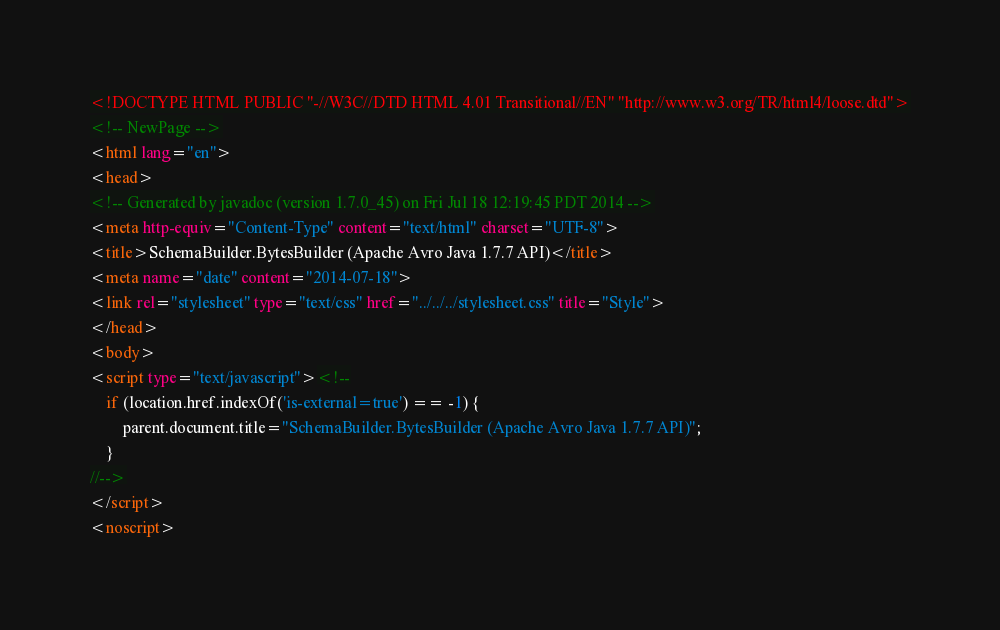<code> <loc_0><loc_0><loc_500><loc_500><_HTML_><!DOCTYPE HTML PUBLIC "-//W3C//DTD HTML 4.01 Transitional//EN" "http://www.w3.org/TR/html4/loose.dtd">
<!-- NewPage -->
<html lang="en">
<head>
<!-- Generated by javadoc (version 1.7.0_45) on Fri Jul 18 12:19:45 PDT 2014 -->
<meta http-equiv="Content-Type" content="text/html" charset="UTF-8">
<title>SchemaBuilder.BytesBuilder (Apache Avro Java 1.7.7 API)</title>
<meta name="date" content="2014-07-18">
<link rel="stylesheet" type="text/css" href="../../../stylesheet.css" title="Style">
</head>
<body>
<script type="text/javascript"><!--
    if (location.href.indexOf('is-external=true') == -1) {
        parent.document.title="SchemaBuilder.BytesBuilder (Apache Avro Java 1.7.7 API)";
    }
//-->
</script>
<noscript></code> 